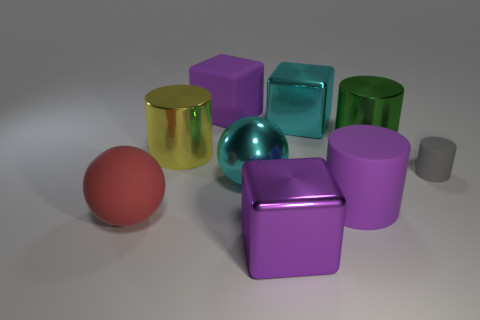Are there any objects that stand out due to their size? Yes, there is. The most prominent object in terms of size is the purple cube in the center, which appears to be larger than the other objects. Can you tell me more about the lighting in the scene? The lighting in the scene is soft and diffuse, creating subtle shadows beneath each object, and adding to the overall calm and balanced atmosphere of the image. The direction of the light appears to be coming from the top, as indicated by the shadow placement. 